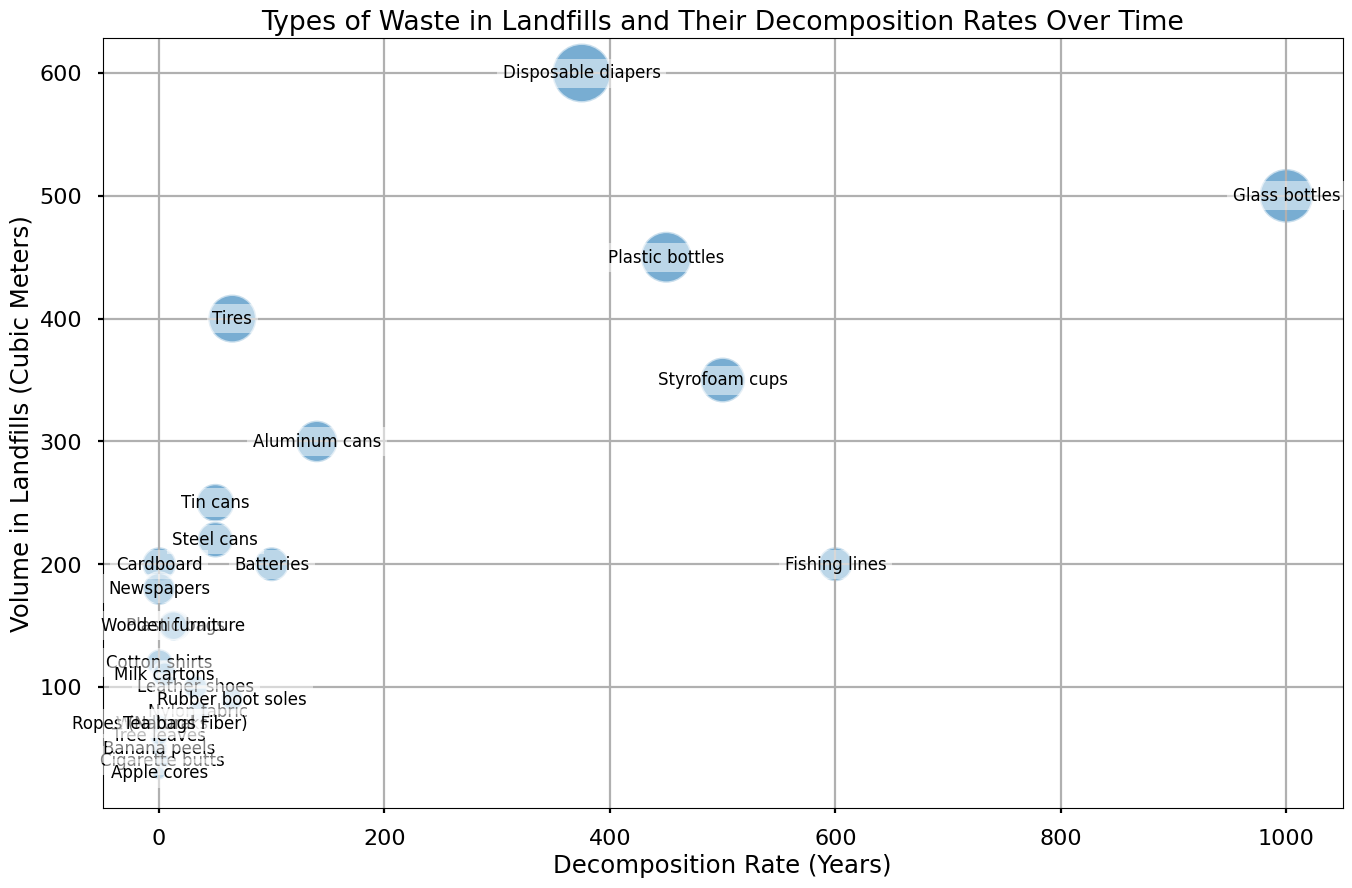Which type of waste has the largest volume in landfills? To determine the type of waste with the largest volume, look for the largest bubble in the plot. This is the type of waste that corresponds to the highest value on the y-axis.
Answer: Disposable diapers Which type of waste takes the longest to decompose? Identify the type of waste located the farthest to the right on the x-axis, as this represents the highest decomposition rate in years.
Answer: Fishing lines How many cubic meters do glass bottles and plastic bottles have in total? Look at the y-axis values for glass bottles and plastic bottles and sum them up: Glass bottles (500 cubic meters) + Plastic bottles (450 cubic meters) = 950 cubic meters.
Answer: 950 cubic meters Which types of waste decompose in less than a year but have a volume over 100 cubic meters? Identify types of waste on the left side of the chart (decompose in less than a year) and check their bubble sizes to see which are over 100 cubic meters. The relevant wastes are Paper, Newspaper, Cardboard, Wool socks, and Cotton shirts.
Answer: Paper, Newspaper, Cardboard, Wool socks, and Cotton shirts Which type of waste has a similar decomposition rate to tin cans but a higher volume in landfills? Look for a type of waste near the same position as tin cans on the x-axis and compare their y-axis positions to find a higher volume. Disposable diapers (250-500 years) have a similar decomposition rate to tin cans (50 years) and a higher volume.
Answer: Disposable diapers What is the decomposition rate range for leather shoes? Identify the position of the leather shoes bubble and read off the decomposition rate from the x-axis labels.
Answer: 25-40 years Which type of waste has the smallest volume but decomposes in less than a year? Find the smallest bubble on the left side of the chart (decomposes in less than a year) and check the label.
Answer: Apple cores How does the volume of rubber boot soles compare to the volume of steel cans? Check the y-axis values for rubber boot soles (90 cubic meters) and steel cans (220 cubic meters), and compare them. Rubber boot soles have a smaller volume than steel cans.
Answer: Rubber boot soles have a smaller volume than steel cans Which types of waste have a decomposition rate range and are between 20 and 100 cubic meters in volume? Identify types of waste with a range in their decomposition rates on the x-axis and with bubble sizes representing volumes between 20 and 100 cubic meters. These are Cigarette butts, Leather shoes, Nylon fabric, Wool socks, and Ropes (Natural Fiber).
Answer: Cigarette butts, Leather shoes, Nylon fabric, Wool socks, and Ropes (Natural Fiber) If you were to add the decomposition rates of plastic bags and nylon fabric, what would be their combined decomposition rate? Identify the decomposition rates for plastic bags (10-20 years) and nylon fabric (30-40 years), calculate their averages, and sum them: (15 + 35) = 50 years.
Answer: 50 years 